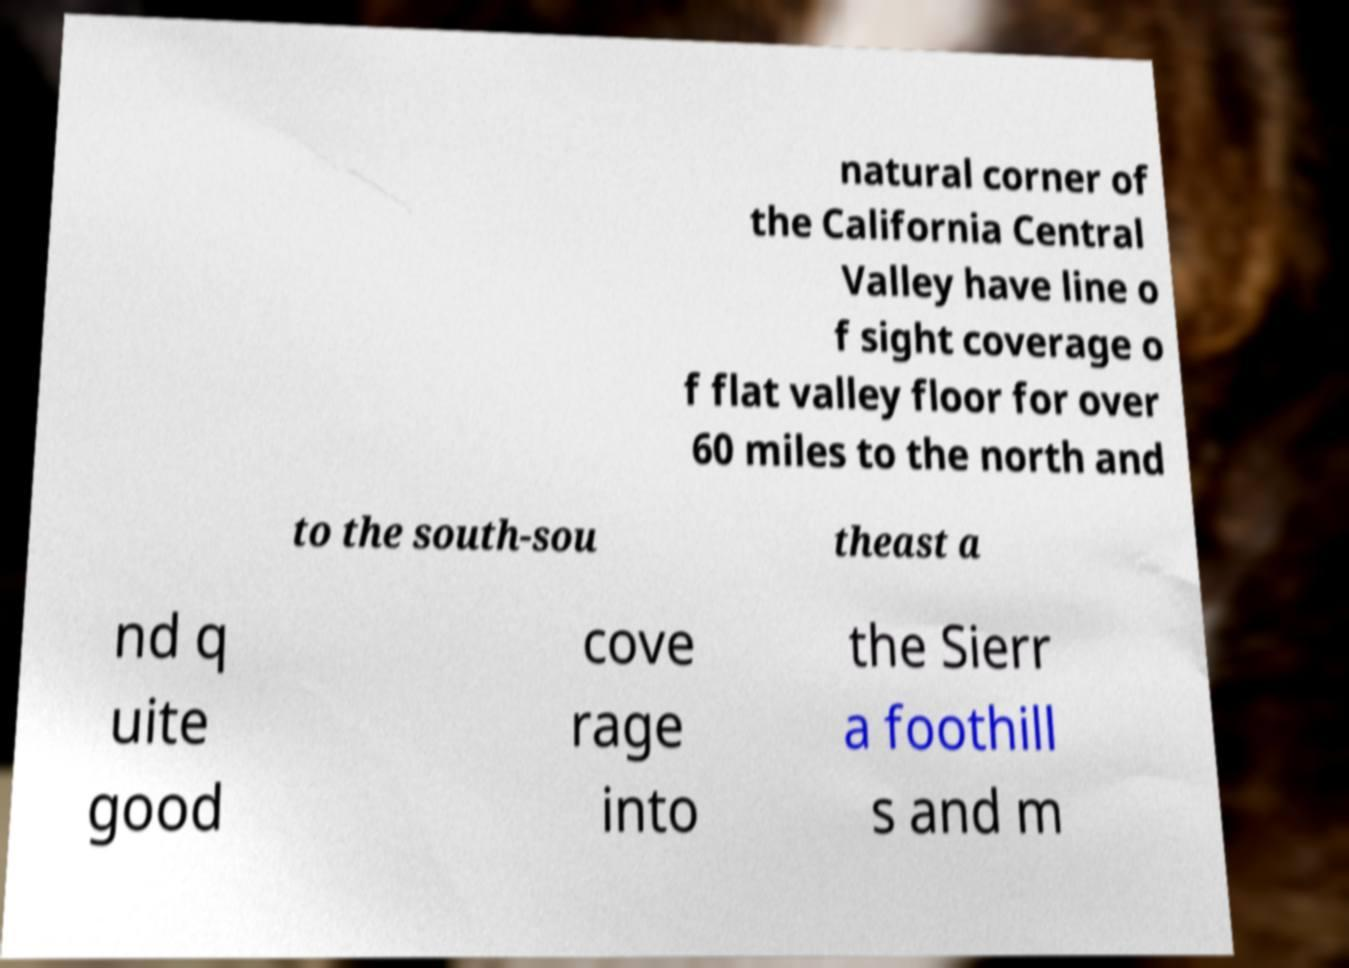Could you assist in decoding the text presented in this image and type it out clearly? natural corner of the California Central Valley have line o f sight coverage o f flat valley floor for over 60 miles to the north and to the south-sou theast a nd q uite good cove rage into the Sierr a foothill s and m 